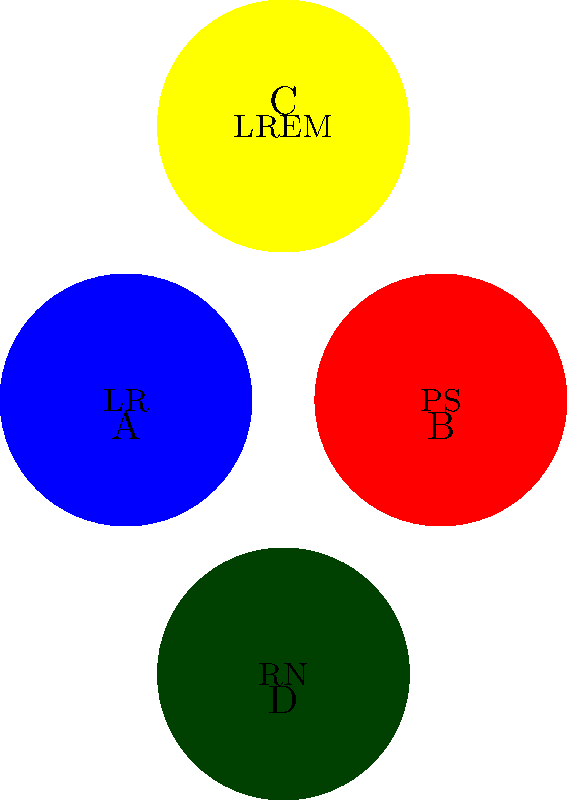As an aspiring politician in France, you're analyzing campaign logos of major political parties. The image shows simplified representations of four party logos, labeled A, B, C, and D. Match each logo to its corresponding political party: Les Républicains (LR), Parti Socialiste (PS), La République En Marche (LREM), and Rassemblement National (RN). To answer this question, we need to analyze the colors and abbreviations used in each logo:

1. Logo A (blue): The blue color is traditionally associated with conservative parties in France. The abbreviation "LR" stands for Les Républicains, which is the main center-right party in France.

2. Logo B (red): Red is historically linked to left-wing and socialist movements. The abbreviation "PS" clearly stands for Parti Socialiste, which is the main center-left party in France.

3. Logo C (yellow): Yellow is not a traditional color for French political parties, but it has been prominently used by Emmanuel Macron's party. The abbreviation "LREM" stands for La République En Marche, which is a centrist party founded by Macron in 2016.

4. Logo D (dark green): While green is usually associated with environmental parties, the dark green used here is distinctive of the far-right party in France. The abbreviation "RN" stands for Rassemblement National (formerly known as Front National).

Therefore, the correct matches are:
A - Les Républicains (LR)
B - Parti Socialiste (PS)
C - La République En Marche (LREM)
D - Rassemblement National (RN)
Answer: A-LR, B-PS, C-LREM, D-RN 